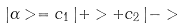<formula> <loc_0><loc_0><loc_500><loc_500>| \alpha > = c _ { 1 } \, | + > + c _ { 2 } \, | - ></formula> 